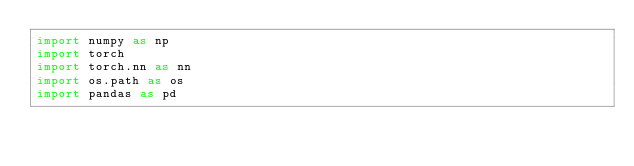Convert code to text. <code><loc_0><loc_0><loc_500><loc_500><_Python_>import numpy as np
import torch
import torch.nn as nn
import os.path as os
import pandas as pd</code> 